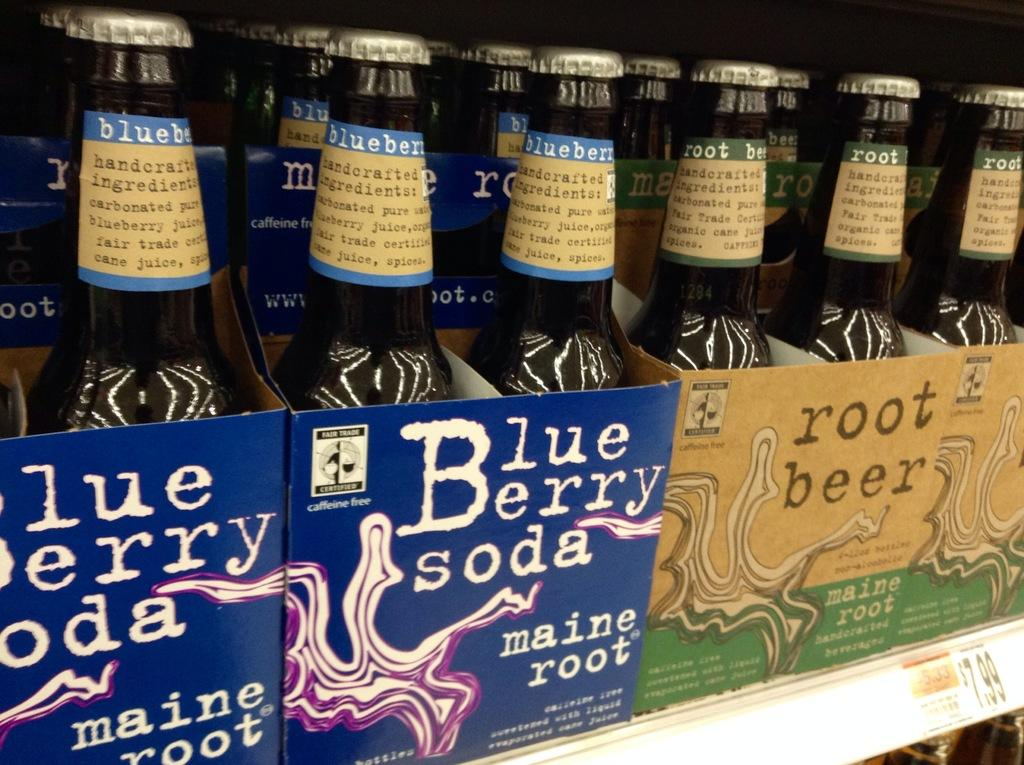<image>
Summarize the visual content of the image. Maine Root blueberry soda and root beer on a store shelf. 